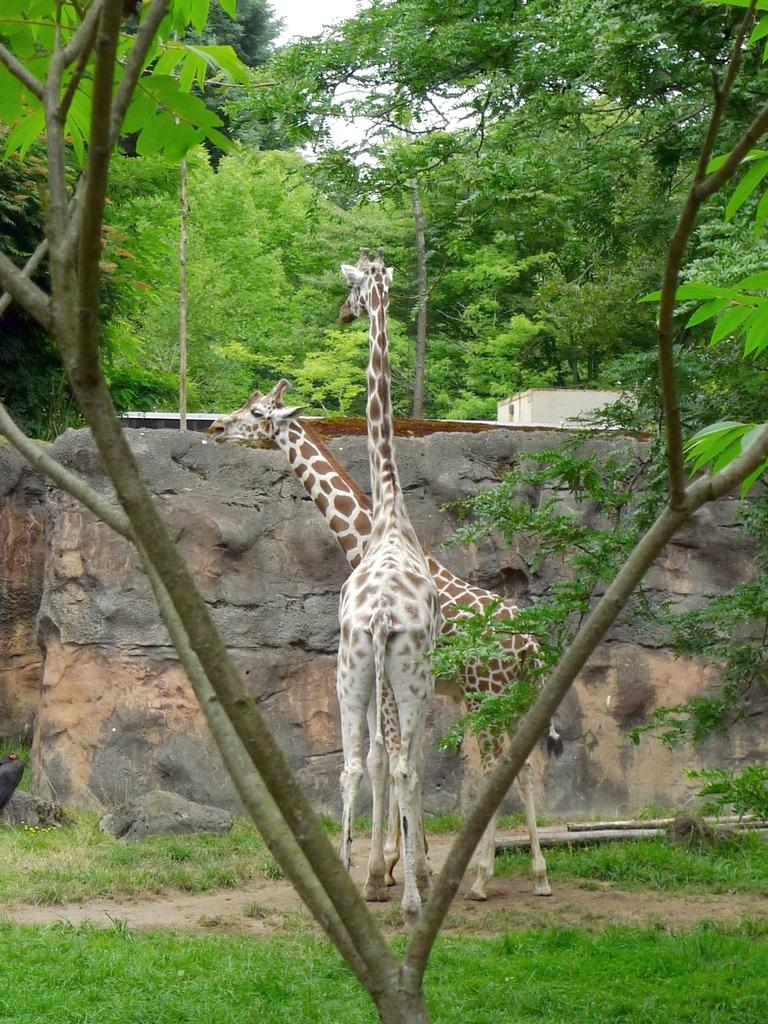How many giraffes are in the image? There are two giraffes in the image. What type of vegetation is on the ground in the image? There is grass on the ground in the image. What other natural elements can be seen in the image? There are trees in the image. What is visible in the background of the image? There is a building in the background of the image. What part of the natural environment is visible in the image? The sky is visible in the image. How much dirt is present on the father's shoes in the image? There is no father or shoes present in the image; it features two giraffes, grass, trees, a building, and the sky. 